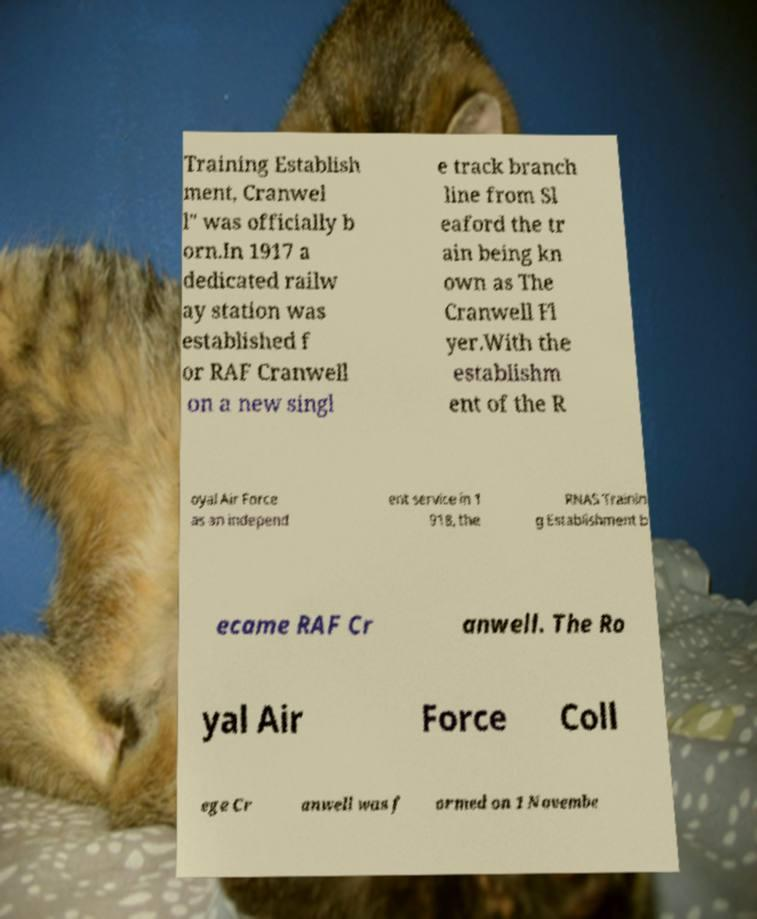Can you accurately transcribe the text from the provided image for me? Training Establish ment, Cranwel l" was officially b orn.In 1917 a dedicated railw ay station was established f or RAF Cranwell on a new singl e track branch line from Sl eaford the tr ain being kn own as The Cranwell Fl yer.With the establishm ent of the R oyal Air Force as an independ ent service in 1 918, the RNAS Trainin g Establishment b ecame RAF Cr anwell. The Ro yal Air Force Coll ege Cr anwell was f ormed on 1 Novembe 